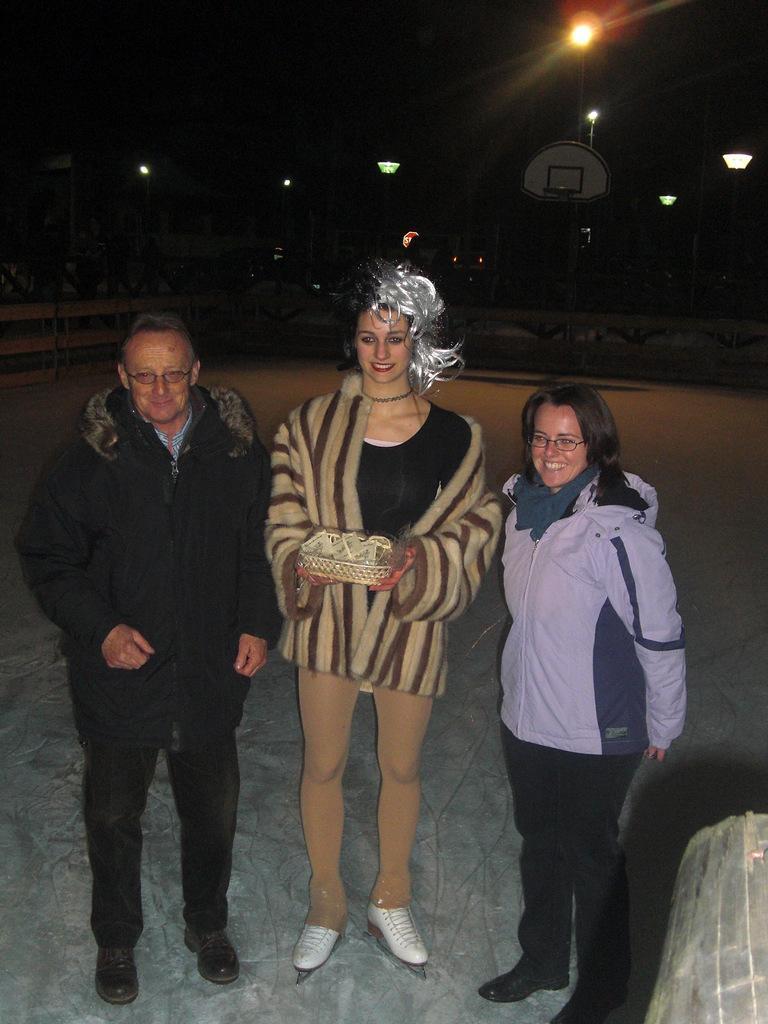Please provide a concise description of this image. In this image, in the middle, we can see three people. On the right corner, we can see a object. In the background, we can see some lights and black color. 